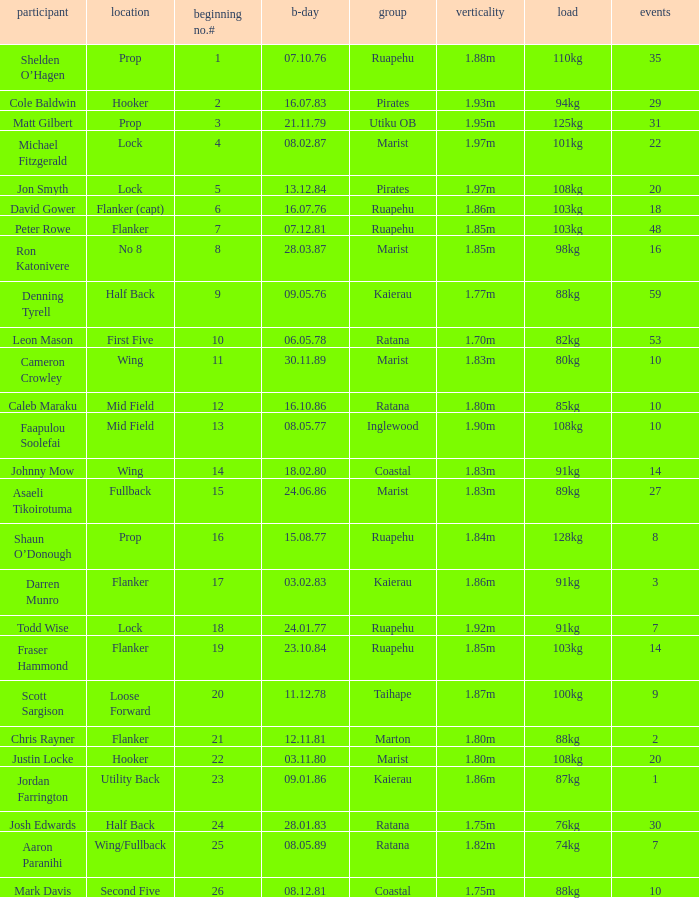What position does the player Todd Wise play in? Lock. 